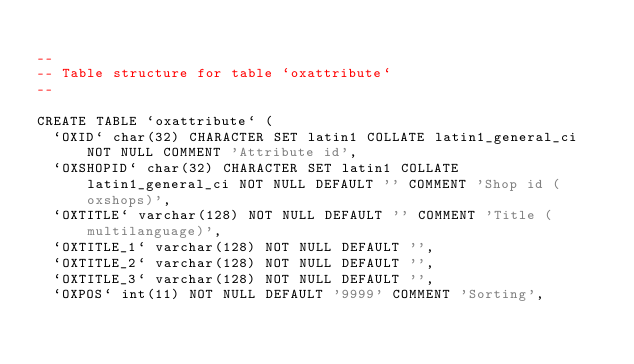Convert code to text. <code><loc_0><loc_0><loc_500><loc_500><_SQL_>
--
-- Table structure for table `oxattribute`
--

CREATE TABLE `oxattribute` (
  `OXID` char(32) CHARACTER SET latin1 COLLATE latin1_general_ci NOT NULL COMMENT 'Attribute id',
  `OXSHOPID` char(32) CHARACTER SET latin1 COLLATE latin1_general_ci NOT NULL DEFAULT '' COMMENT 'Shop id (oxshops)',
  `OXTITLE` varchar(128) NOT NULL DEFAULT '' COMMENT 'Title (multilanguage)',
  `OXTITLE_1` varchar(128) NOT NULL DEFAULT '',
  `OXTITLE_2` varchar(128) NOT NULL DEFAULT '',
  `OXTITLE_3` varchar(128) NOT NULL DEFAULT '',
  `OXPOS` int(11) NOT NULL DEFAULT '9999' COMMENT 'Sorting',</code> 